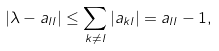<formula> <loc_0><loc_0><loc_500><loc_500>| \lambda - a _ { l l } | \leq \sum _ { k \neq l } | a _ { k l } | = a _ { l l } - 1 ,</formula> 